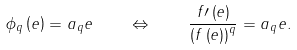Convert formula to latex. <formula><loc_0><loc_0><loc_500><loc_500>\phi _ { q } \left ( e \right ) = a _ { q } e \quad \Leftrightarrow \quad \frac { f \prime \left ( e \right ) } { \left ( f \left ( e \right ) \right ) ^ { q } } = a _ { q } e .</formula> 